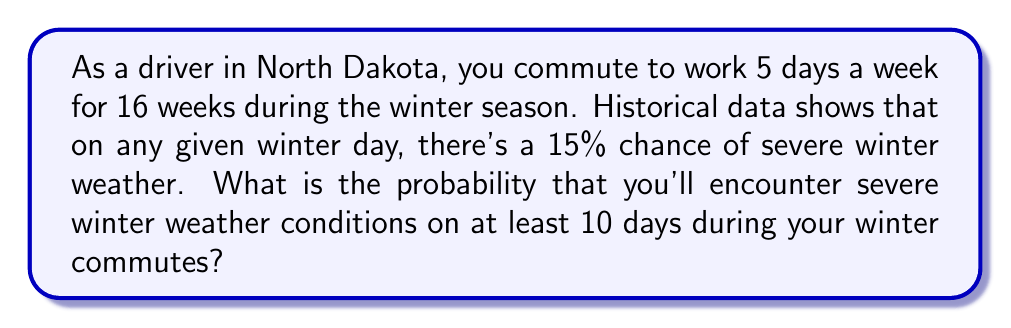Can you answer this question? Let's approach this step-by-step:

1) First, we need to calculate the total number of commuting days:
   5 days/week × 16 weeks = 80 days

2) We can model this scenario using a binomial distribution, where:
   n = 80 (number of trials)
   p = 0.15 (probability of severe weather on any given day)
   k ≥ 10 (we want at least 10 severe weather days)

3) The probability of at least 10 severe weather days is equal to 1 minus the probability of 9 or fewer severe weather days:

   $P(X \geq 10) = 1 - P(X \leq 9)$

4) We can calculate this using the cumulative binomial probability function:

   $P(X \geq 10) = 1 - \sum_{k=0}^{9} \binom{80}{k} (0.15)^k (0.85)^{80-k}$

5) This calculation is complex to do by hand, so we would typically use statistical software or a calculator with binomial probability functions.

6) Using such a tool, we find:

   $P(X \geq 10) \approx 0.8734$

7) Converting to a percentage: 0.8734 × 100% ≈ 87.34%

This high probability might be surprising for a responsible driver in North Dakota, hence fitting the given persona.
Answer: 87.34% 